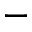<formula> <loc_0><loc_0><loc_500><loc_500>\mathfrak { - }</formula> 